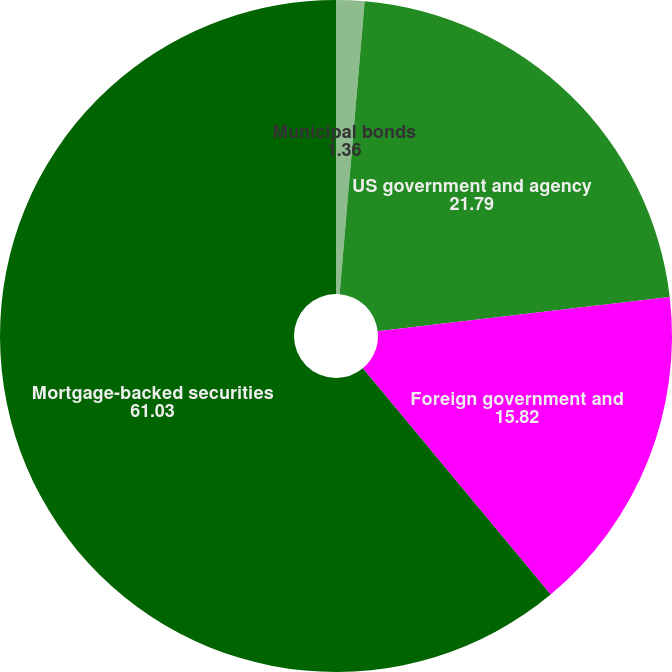Convert chart. <chart><loc_0><loc_0><loc_500><loc_500><pie_chart><fcel>Municipal bonds<fcel>US government and agency<fcel>Foreign government and<fcel>Mortgage-backed securities<nl><fcel>1.36%<fcel>21.79%<fcel>15.82%<fcel>61.03%<nl></chart> 